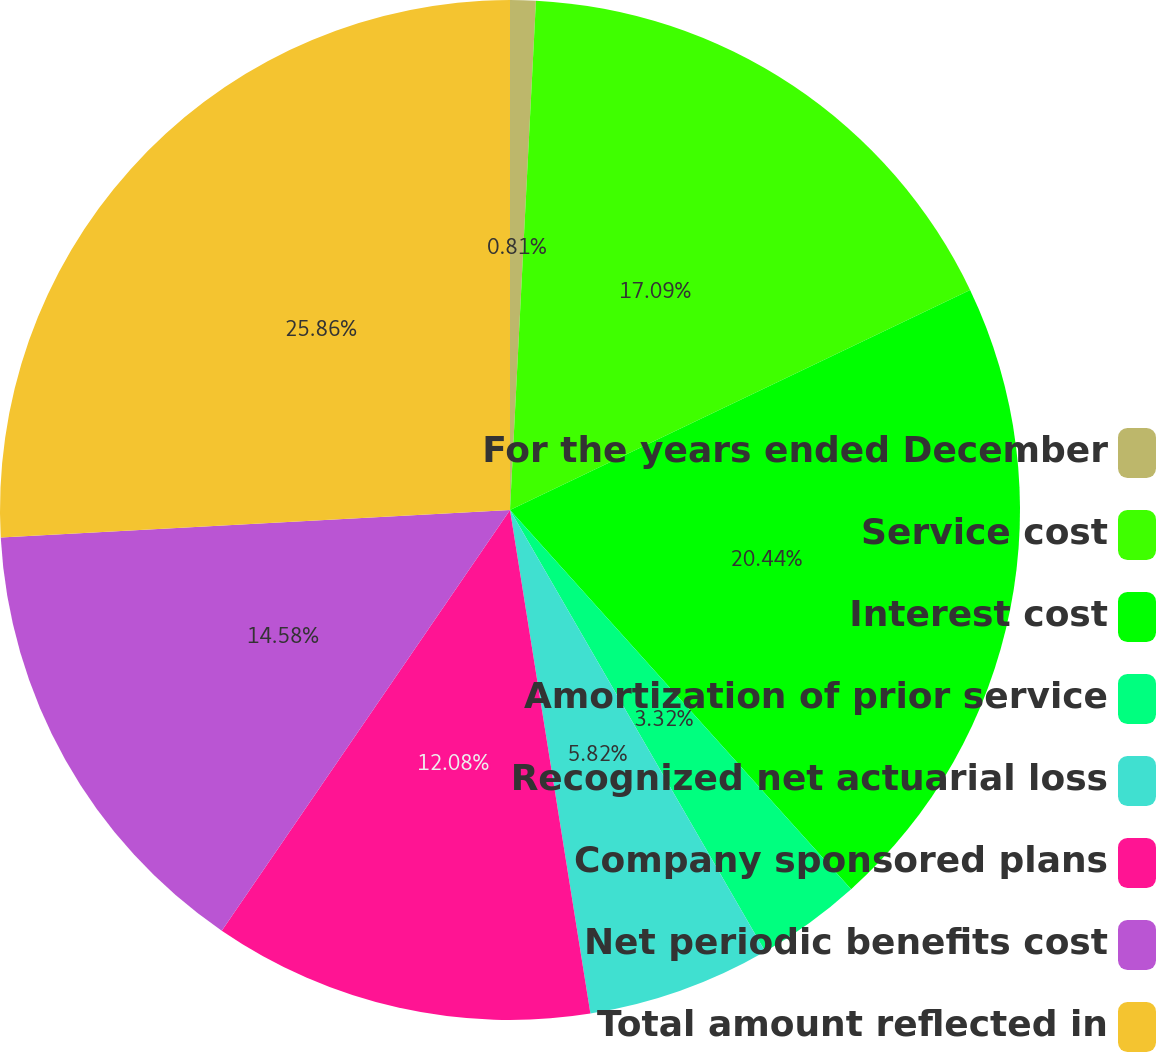<chart> <loc_0><loc_0><loc_500><loc_500><pie_chart><fcel>For the years ended December<fcel>Service cost<fcel>Interest cost<fcel>Amortization of prior service<fcel>Recognized net actuarial loss<fcel>Company sponsored plans<fcel>Net periodic benefits cost<fcel>Total amount reflected in<nl><fcel>0.81%<fcel>17.09%<fcel>20.44%<fcel>3.32%<fcel>5.82%<fcel>12.08%<fcel>14.58%<fcel>25.86%<nl></chart> 